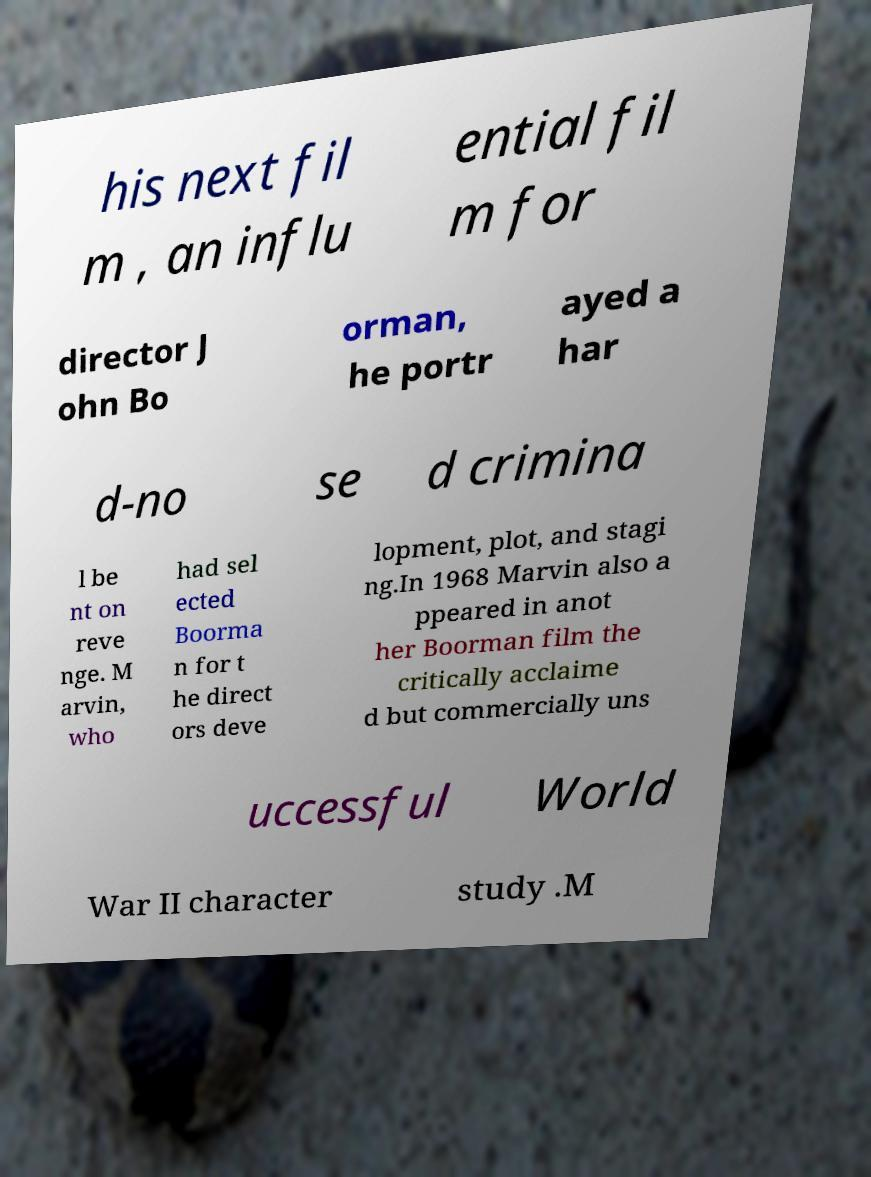There's text embedded in this image that I need extracted. Can you transcribe it verbatim? his next fil m , an influ ential fil m for director J ohn Bo orman, he portr ayed a har d-no se d crimina l be nt on reve nge. M arvin, who had sel ected Boorma n for t he direct ors deve lopment, plot, and stagi ng.In 1968 Marvin also a ppeared in anot her Boorman film the critically acclaime d but commercially uns uccessful World War II character study .M 